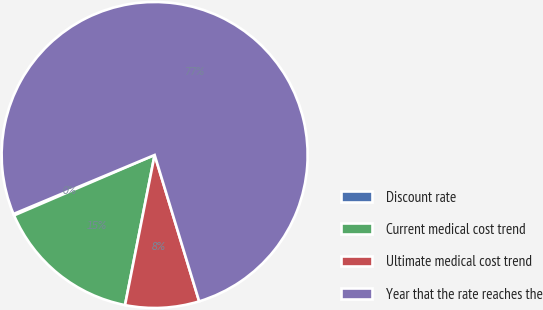<chart> <loc_0><loc_0><loc_500><loc_500><pie_chart><fcel>Discount rate<fcel>Current medical cost trend<fcel>Ultimate medical cost trend<fcel>Year that the rate reaches the<nl><fcel>0.16%<fcel>15.44%<fcel>7.8%<fcel>76.6%<nl></chart> 